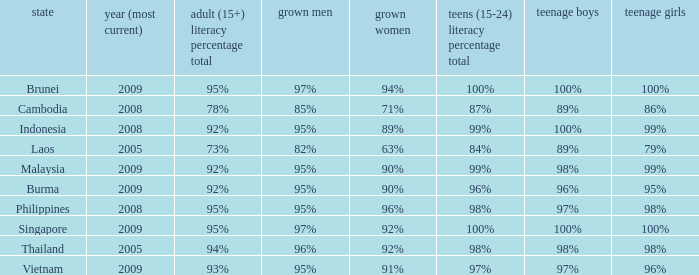What country has a Youth (15-24) Literacy Rate Total of 99%, and a Youth Men of 98%? Malaysia. 